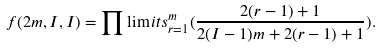Convert formula to latex. <formula><loc_0><loc_0><loc_500><loc_500>f ( 2 m , I , I ) = \prod \lim i t s _ { r = 1 } ^ { m } ( \frac { 2 ( r - 1 ) + 1 } { 2 ( I - 1 ) m + 2 ( r - 1 ) + 1 } ) .</formula> 